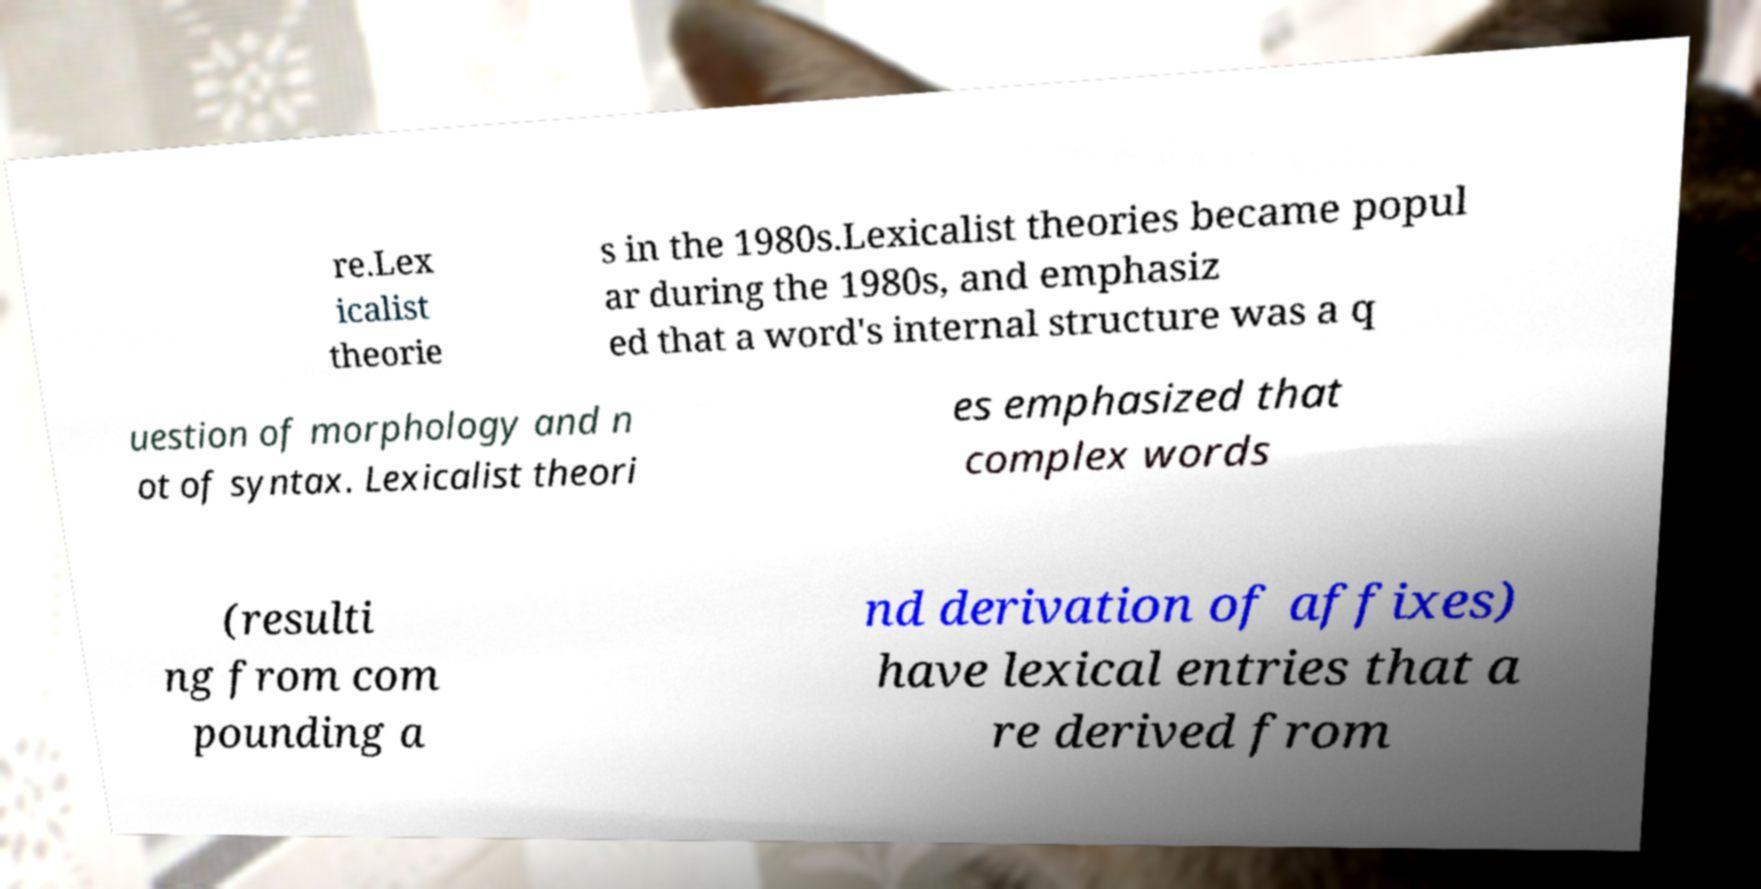I need the written content from this picture converted into text. Can you do that? re.Lex icalist theorie s in the 1980s.Lexicalist theories became popul ar during the 1980s, and emphasiz ed that a word's internal structure was a q uestion of morphology and n ot of syntax. Lexicalist theori es emphasized that complex words (resulti ng from com pounding a nd derivation of affixes) have lexical entries that a re derived from 